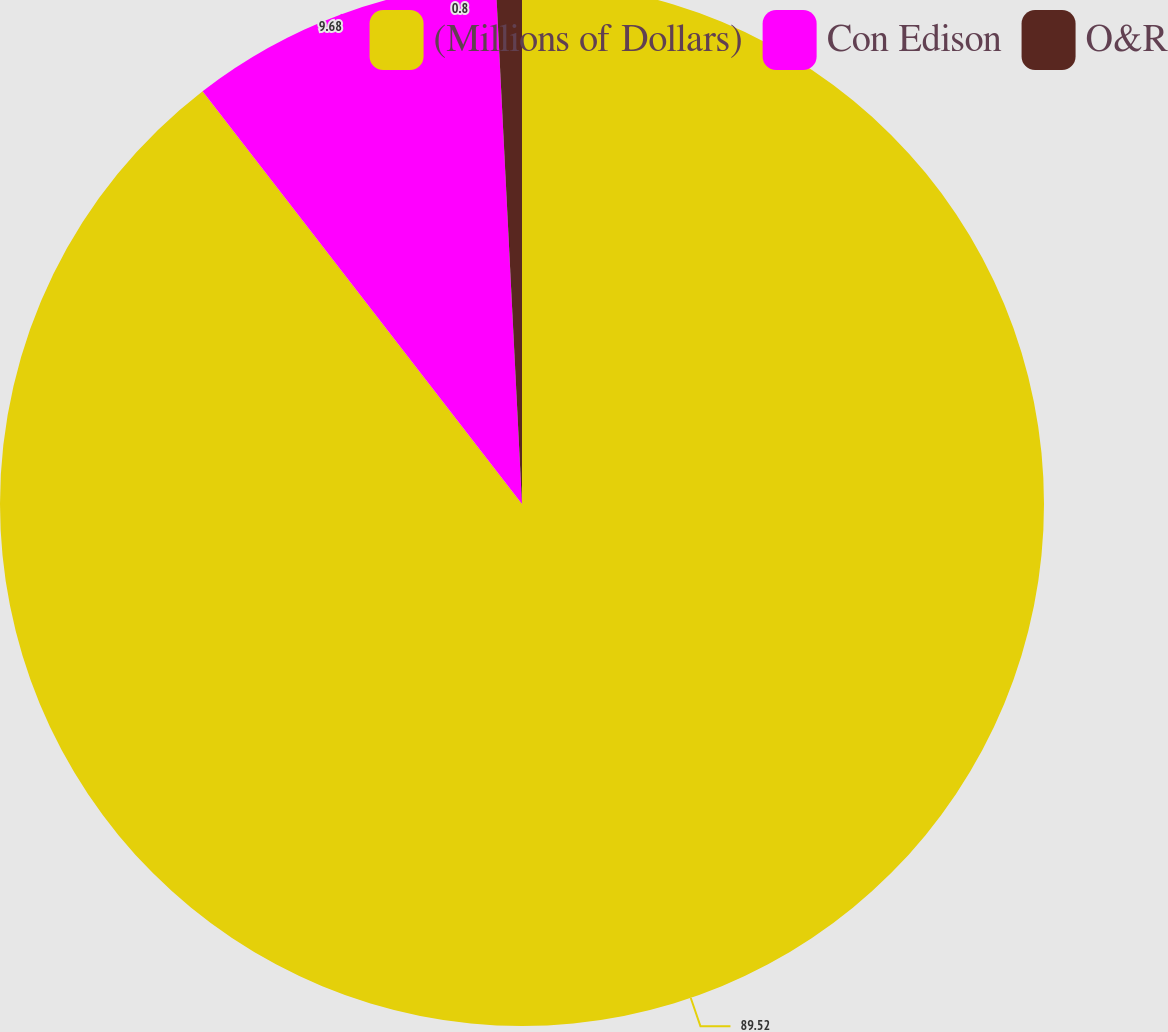<chart> <loc_0><loc_0><loc_500><loc_500><pie_chart><fcel>(Millions of Dollars)<fcel>Con Edison<fcel>O&R<nl><fcel>89.52%<fcel>9.68%<fcel>0.8%<nl></chart> 